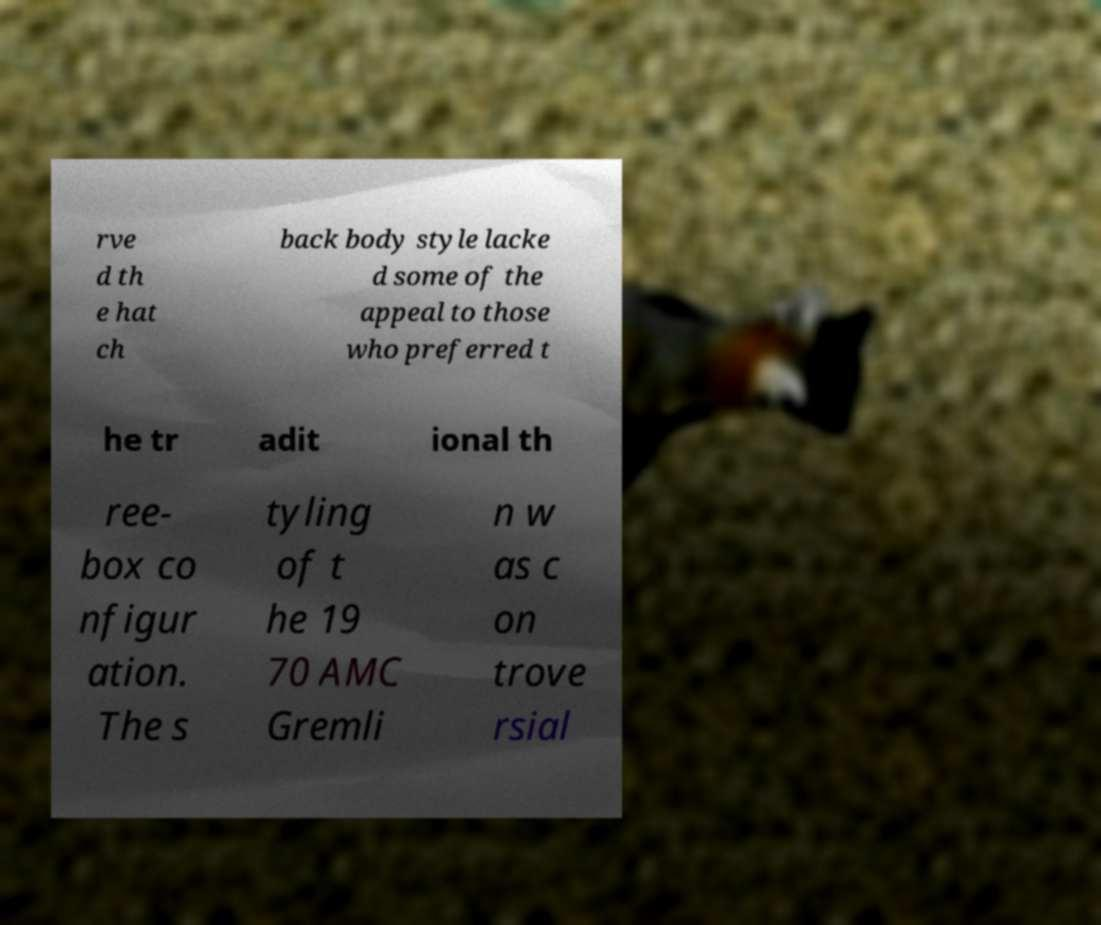Can you accurately transcribe the text from the provided image for me? rve d th e hat ch back body style lacke d some of the appeal to those who preferred t he tr adit ional th ree- box co nfigur ation. The s tyling of t he 19 70 AMC Gremli n w as c on trove rsial 